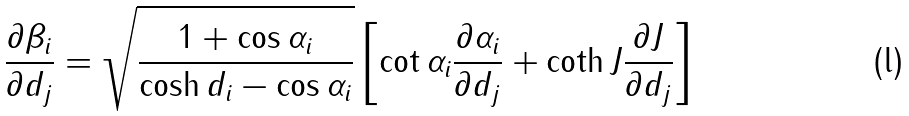<formula> <loc_0><loc_0><loc_500><loc_500>\frac { \partial \beta _ { i } } { \partial d _ { j } } = \sqrt { \frac { 1 + \cos \alpha _ { i } } { \cosh d _ { i } - \cos \alpha _ { i } } } \left [ \cot \alpha _ { i } \frac { \partial \alpha _ { i } } { \partial d _ { j } } + \coth J \frac { \partial J } { \partial d _ { j } } \right ]</formula> 